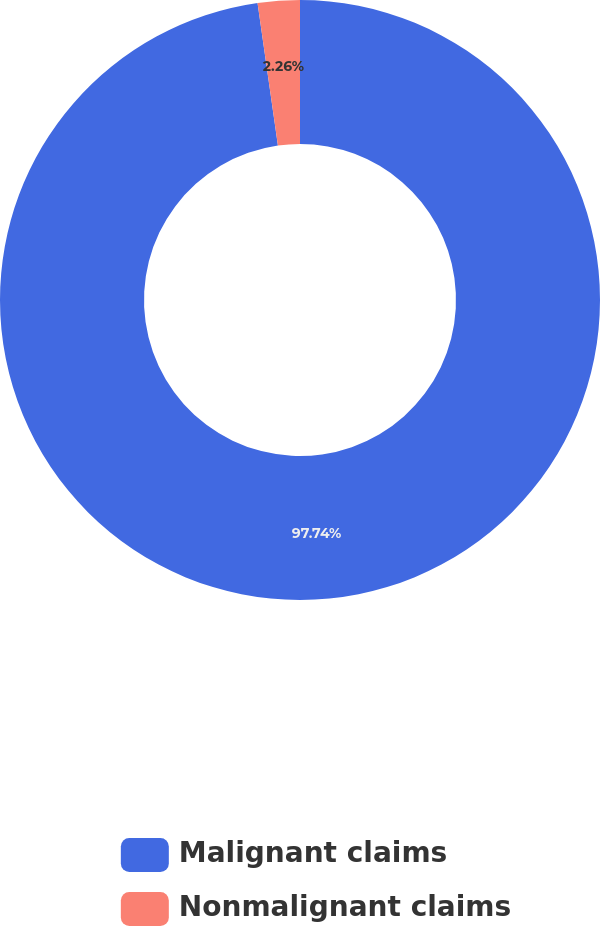Convert chart. <chart><loc_0><loc_0><loc_500><loc_500><pie_chart><fcel>Malignant claims<fcel>Nonmalignant claims<nl><fcel>97.74%<fcel>2.26%<nl></chart> 